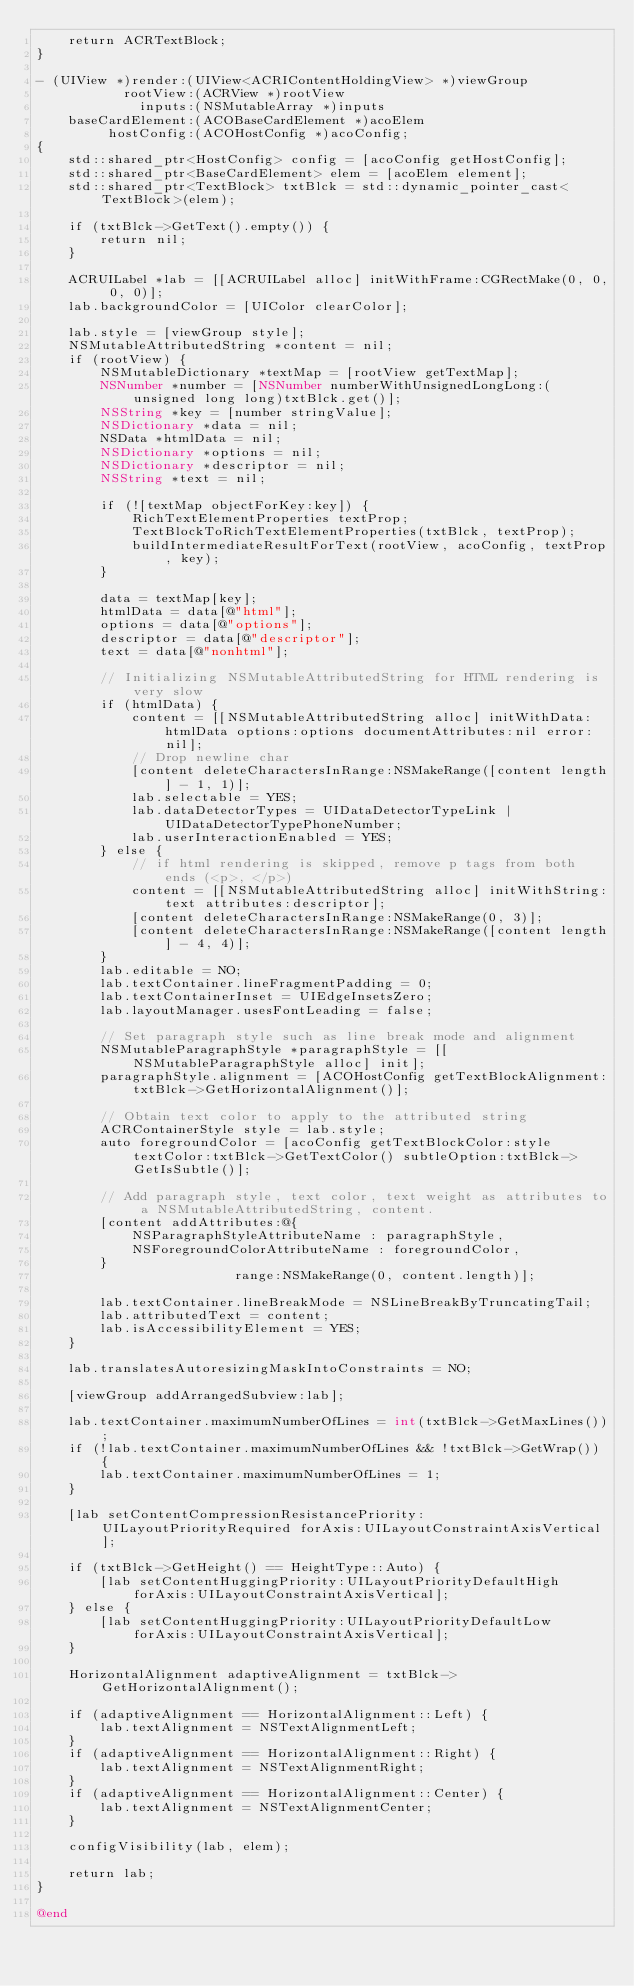<code> <loc_0><loc_0><loc_500><loc_500><_ObjectiveC_>    return ACRTextBlock;
}

- (UIView *)render:(UIView<ACRIContentHoldingView> *)viewGroup
           rootView:(ACRView *)rootView
             inputs:(NSMutableArray *)inputs
    baseCardElement:(ACOBaseCardElement *)acoElem
         hostConfig:(ACOHostConfig *)acoConfig;
{
    std::shared_ptr<HostConfig> config = [acoConfig getHostConfig];
    std::shared_ptr<BaseCardElement> elem = [acoElem element];
    std::shared_ptr<TextBlock> txtBlck = std::dynamic_pointer_cast<TextBlock>(elem);

    if (txtBlck->GetText().empty()) {
        return nil;
    }

    ACRUILabel *lab = [[ACRUILabel alloc] initWithFrame:CGRectMake(0, 0, 0, 0)];
    lab.backgroundColor = [UIColor clearColor];

    lab.style = [viewGroup style];
    NSMutableAttributedString *content = nil;
    if (rootView) {
        NSMutableDictionary *textMap = [rootView getTextMap];
        NSNumber *number = [NSNumber numberWithUnsignedLongLong:(unsigned long long)txtBlck.get()];
        NSString *key = [number stringValue];
        NSDictionary *data = nil;
        NSData *htmlData = nil;
        NSDictionary *options = nil;
        NSDictionary *descriptor = nil;
        NSString *text = nil;

        if (![textMap objectForKey:key]) {
            RichTextElementProperties textProp;
            TextBlockToRichTextElementProperties(txtBlck, textProp);
            buildIntermediateResultForText(rootView, acoConfig, textProp, key);
        }

        data = textMap[key];
        htmlData = data[@"html"];
        options = data[@"options"];
        descriptor = data[@"descriptor"];
        text = data[@"nonhtml"];

        // Initializing NSMutableAttributedString for HTML rendering is very slow
        if (htmlData) {
            content = [[NSMutableAttributedString alloc] initWithData:htmlData options:options documentAttributes:nil error:nil];
            // Drop newline char
            [content deleteCharactersInRange:NSMakeRange([content length] - 1, 1)];
            lab.selectable = YES;
            lab.dataDetectorTypes = UIDataDetectorTypeLink | UIDataDetectorTypePhoneNumber;
            lab.userInteractionEnabled = YES;
        } else {
            // if html rendering is skipped, remove p tags from both ends (<p>, </p>)
            content = [[NSMutableAttributedString alloc] initWithString:text attributes:descriptor];
            [content deleteCharactersInRange:NSMakeRange(0, 3)];
            [content deleteCharactersInRange:NSMakeRange([content length] - 4, 4)];
        }
        lab.editable = NO;
        lab.textContainer.lineFragmentPadding = 0;
        lab.textContainerInset = UIEdgeInsetsZero;
        lab.layoutManager.usesFontLeading = false;

        // Set paragraph style such as line break mode and alignment
        NSMutableParagraphStyle *paragraphStyle = [[NSMutableParagraphStyle alloc] init];
        paragraphStyle.alignment = [ACOHostConfig getTextBlockAlignment:txtBlck->GetHorizontalAlignment()];

        // Obtain text color to apply to the attributed string
        ACRContainerStyle style = lab.style;
        auto foregroundColor = [acoConfig getTextBlockColor:style textColor:txtBlck->GetTextColor() subtleOption:txtBlck->GetIsSubtle()];

        // Add paragraph style, text color, text weight as attributes to a NSMutableAttributedString, content.
        [content addAttributes:@{
            NSParagraphStyleAttributeName : paragraphStyle,
            NSForegroundColorAttributeName : foregroundColor,
        }
                         range:NSMakeRange(0, content.length)];

        lab.textContainer.lineBreakMode = NSLineBreakByTruncatingTail;
        lab.attributedText = content;
        lab.isAccessibilityElement = YES;
    }

    lab.translatesAutoresizingMaskIntoConstraints = NO;

    [viewGroup addArrangedSubview:lab];

    lab.textContainer.maximumNumberOfLines = int(txtBlck->GetMaxLines());
    if (!lab.textContainer.maximumNumberOfLines && !txtBlck->GetWrap()) {
        lab.textContainer.maximumNumberOfLines = 1;
    }

    [lab setContentCompressionResistancePriority:UILayoutPriorityRequired forAxis:UILayoutConstraintAxisVertical];

    if (txtBlck->GetHeight() == HeightType::Auto) {
        [lab setContentHuggingPriority:UILayoutPriorityDefaultHigh forAxis:UILayoutConstraintAxisVertical];
    } else {
        [lab setContentHuggingPriority:UILayoutPriorityDefaultLow forAxis:UILayoutConstraintAxisVertical];
    }

    HorizontalAlignment adaptiveAlignment = txtBlck->GetHorizontalAlignment();

    if (adaptiveAlignment == HorizontalAlignment::Left) {
        lab.textAlignment = NSTextAlignmentLeft;
    }
    if (adaptiveAlignment == HorizontalAlignment::Right) {
        lab.textAlignment = NSTextAlignmentRight;
    }
    if (adaptiveAlignment == HorizontalAlignment::Center) {
        lab.textAlignment = NSTextAlignmentCenter;
    }

    configVisibility(lab, elem);

    return lab;
}

@end
</code> 